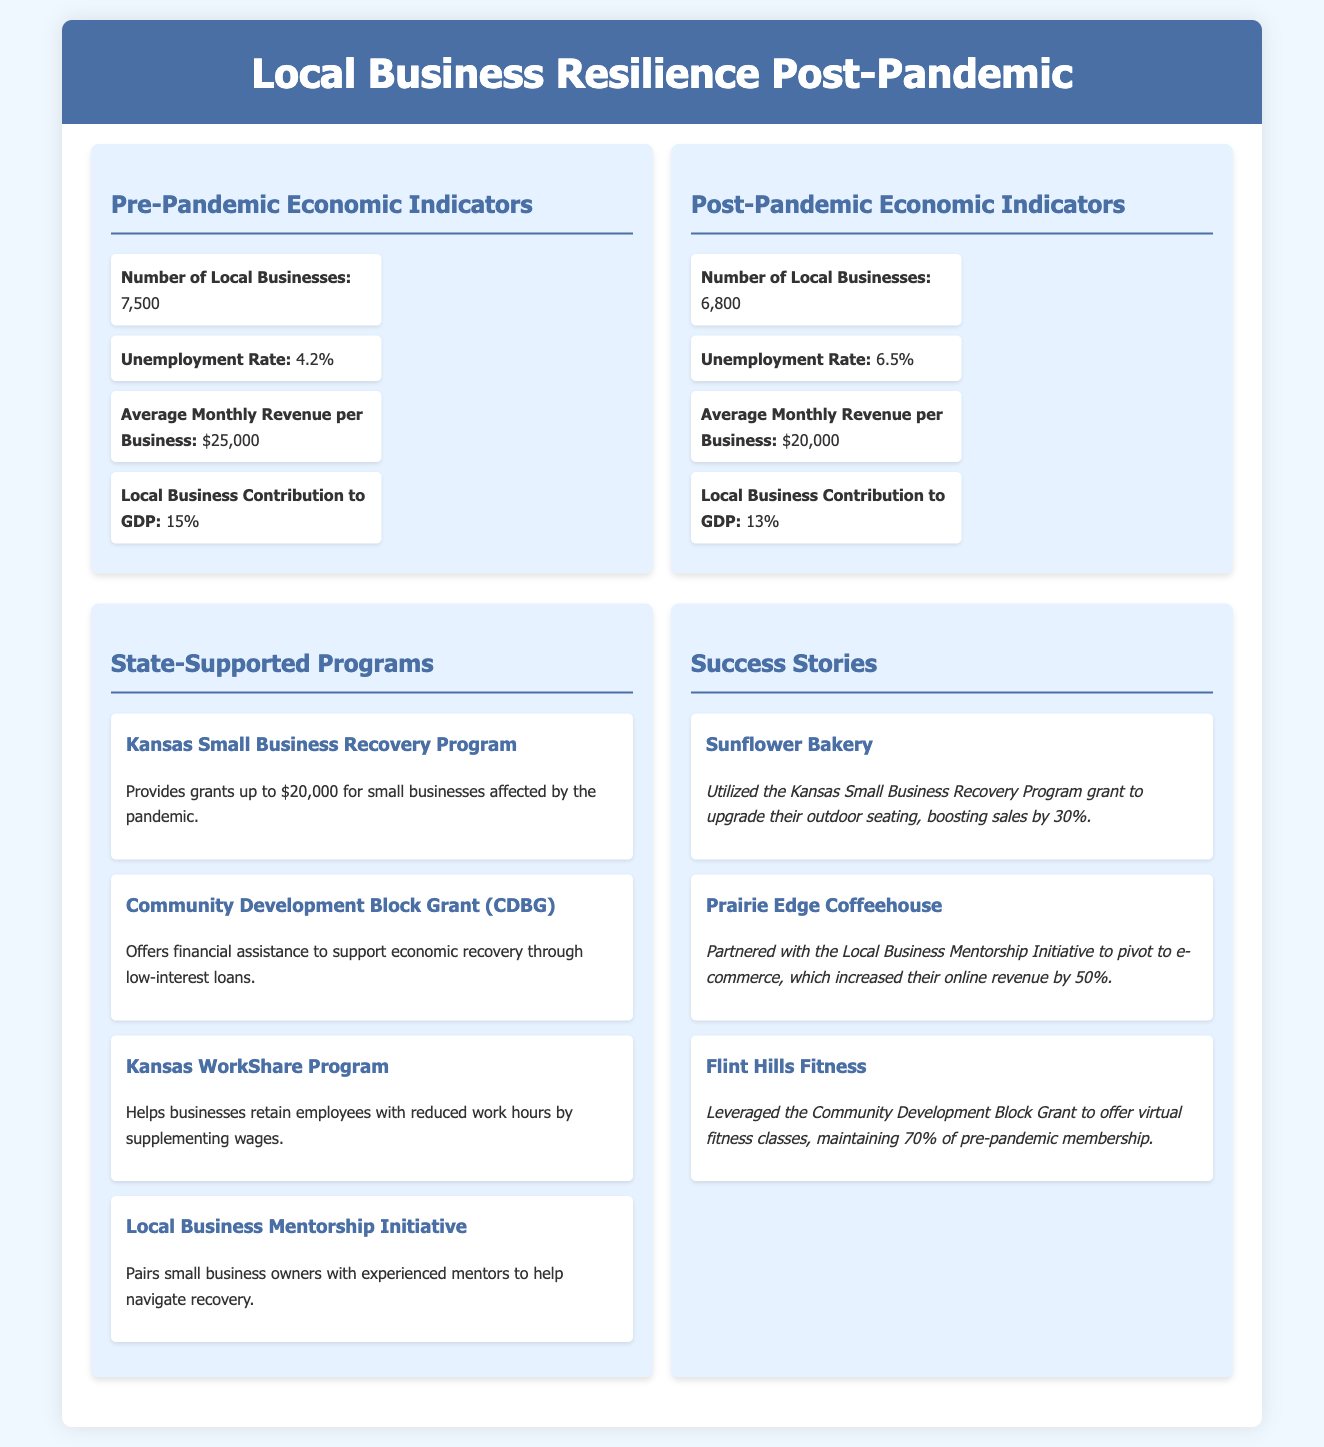What was the number of local businesses pre-pandemic? The document states that there were 7,500 local businesses before the pandemic.
Answer: 7,500 What is the post-pandemic unemployment rate? The post-pandemic unemployment rate presented in the infographic is 6.5%.
Answer: 6.5% What grant amount does the Kansas Small Business Recovery Program provide? According to the document, the Kansas Small Business Recovery Program provides grants up to $20,000.
Answer: $20,000 How much did Sunflower Bakery's sales increase after receiving support? The success story of Sunflower Bakery indicates their sales increased by 30% after utilizing the grant.
Answer: 30% What is the local business contribution to GDP pre-pandemic? The document specifies that local businesses contributed 15% to the GDP before the pandemic.
Answer: 15% Which program helps businesses retain employees with reduced hours? The Kansas WorkShare Program is designed to help businesses retain employees who have reduced work hours.
Answer: Kansas WorkShare Program How many local businesses are reported post-pandemic? The document indicates there are 6,800 local businesses after the pandemic.
Answer: 6,800 What percentage increase in online revenue did Prairie Edge Coffeehouse achieve? Prairie Edge Coffeehouse achieved a 50% increase in online revenue by pivoting to e-commerce.
Answer: 50% What initiative pairs small business owners with experienced mentors? The Local Business Mentorship Initiative pairs business owners with experienced mentors for support during recovery.
Answer: Local Business Mentorship Initiative 